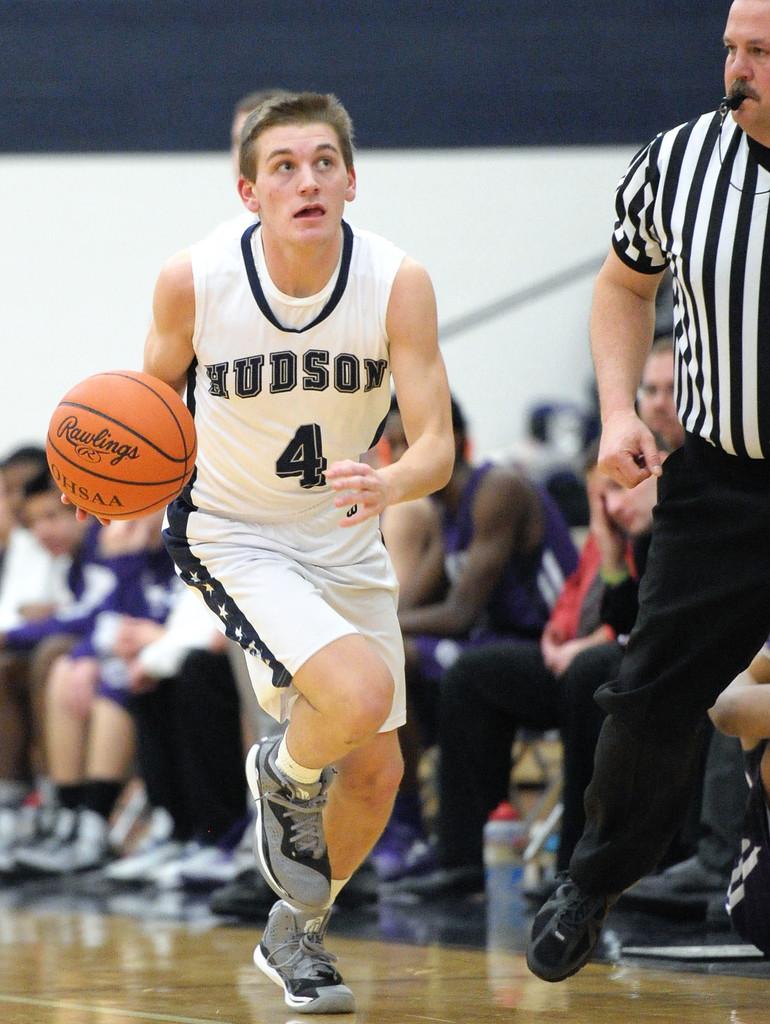What is the name of school on jersey?
Make the answer very short. Hudson. What is the player number shown on the jersey?
Provide a succinct answer. 4. 